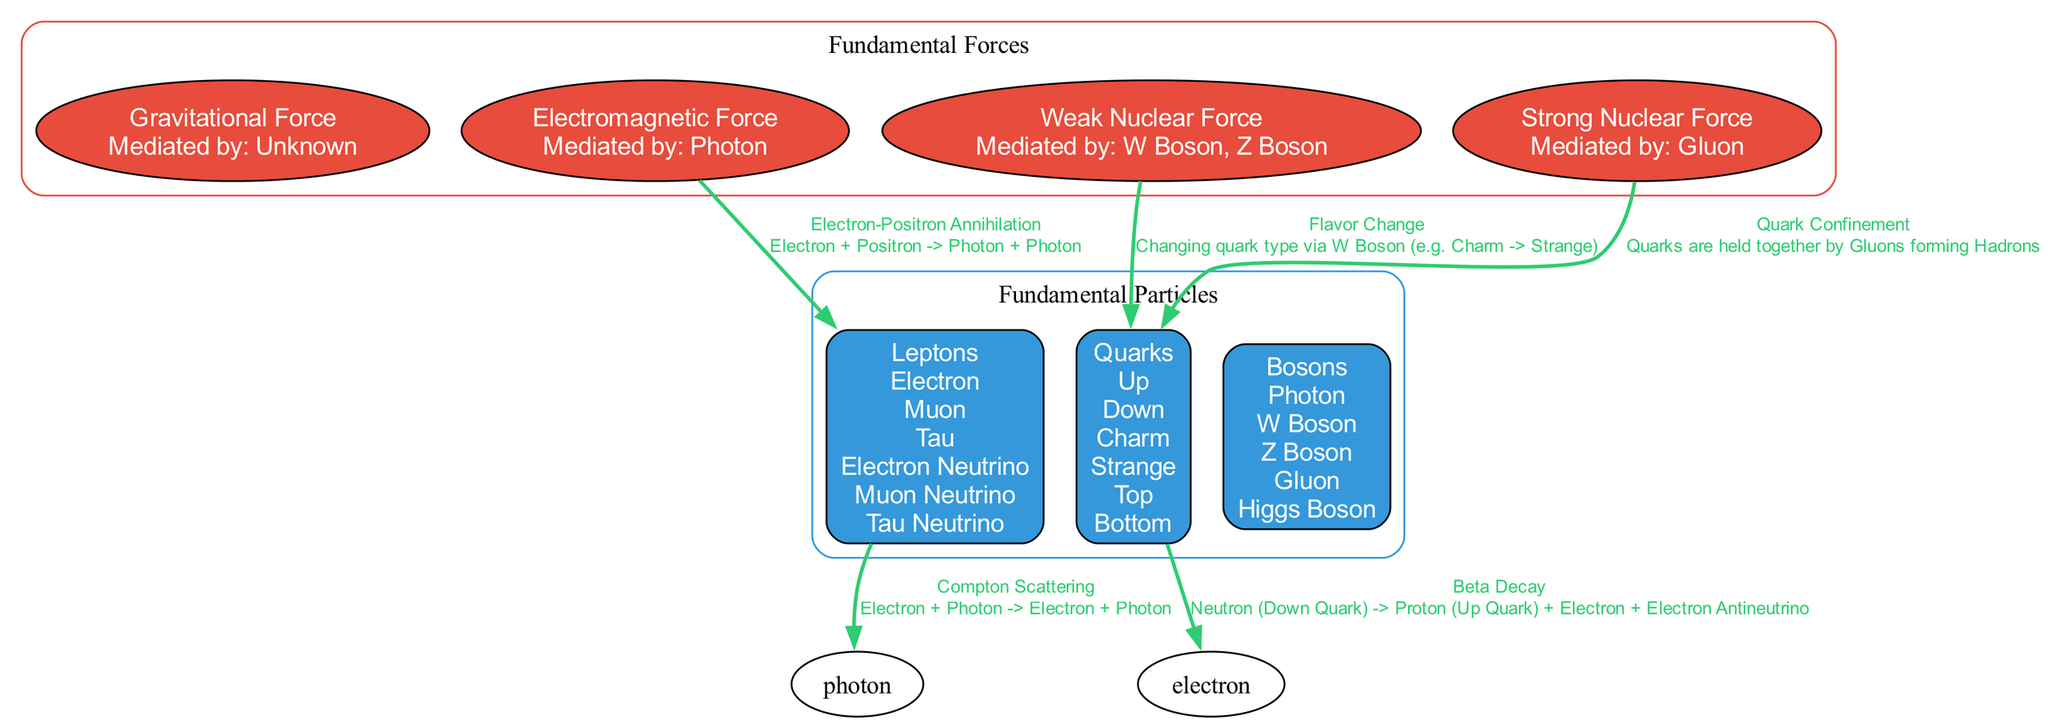What are the subtypes of quarks? The diagram clearly lists the subtypes of quarks under the "Quarks" node, which are Up, Down, Charm, Strange, Top, and Bottom.
Answer: Up, Down, Charm, Strange, Top, Bottom How many fundamental forces are illustrated in the diagram? By checking the "Fundamental Forces" cluster in the diagram, we can count four forces: Gravitational Force, Electromagnetic Force, Weak Nuclear Force, and Strong Nuclear Force.
Answer: 4 What interaction is mediated by the photon? The edge connecting the "Electromagnetic Force" and "Leptons" nodes indicates that the interaction is "Electron-Positron Annihilation" mediated by the photon.
Answer: Electron-Positron Annihilation Which fundamental force is responsible for quark confinement? In the diagram, the "Strong Nuclear Force" is linked to the "Quarks" node with the label "Quark Confinement," indicating it is responsible for this interaction.
Answer: Strong Nuclear Force What decay process is represented between quarks and leptons? The diagram presents a direct edge from the "Quarks" node to the "Leptons" node labeled "Beta Decay," outlining the specific decay process occurring between these particles.
Answer: Beta Decay What mediates the weak nuclear force? The "Weak Nuclear Force" node specifies that it is mediated by W Boson and Z Boson, which is mentioned in the node details of the force.
Answer: W Boson, Z Boson In the context of flavor change, which particle type is influenced? The label "Flavor Change" is connected to the "Quarks" node in the context of utilizing the W Boson for changing quark types, indicating that quarks are the influenced particles.
Answer: Quarks How many types of leptons are listed in the diagram? Looking inside the "Leptons" node, there are six subtypes: Electron, Muon, Tau, Electron Neutrino, Muon Neutrino, and Tau Neutrino. Counting these gives us six types.
Answer: 6 